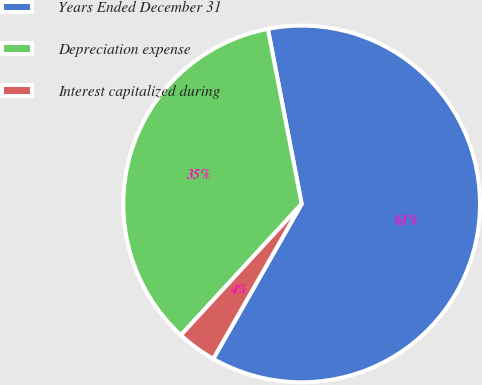Convert chart. <chart><loc_0><loc_0><loc_500><loc_500><pie_chart><fcel>Years Ended December 31<fcel>Depreciation expense<fcel>Interest capitalized during<nl><fcel>61.29%<fcel>35.12%<fcel>3.59%<nl></chart> 